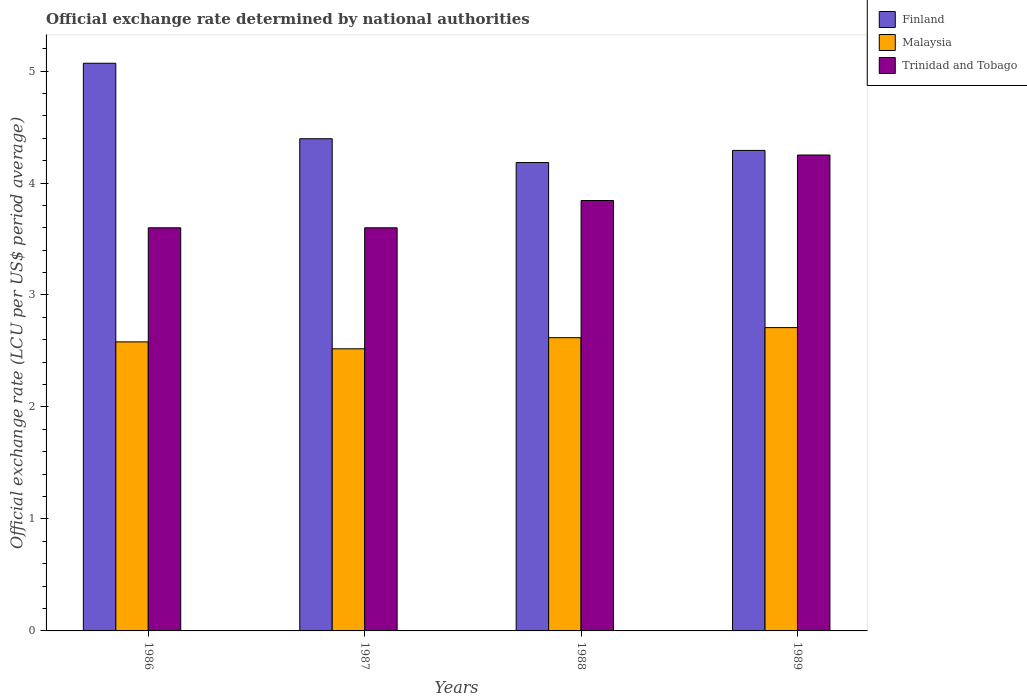Are the number of bars on each tick of the X-axis equal?
Your answer should be compact. Yes. How many bars are there on the 3rd tick from the left?
Offer a very short reply. 3. What is the official exchange rate in Finland in 1987?
Keep it short and to the point. 4.4. Across all years, what is the maximum official exchange rate in Finland?
Make the answer very short. 5.07. In which year was the official exchange rate in Finland minimum?
Ensure brevity in your answer.  1988. What is the total official exchange rate in Trinidad and Tobago in the graph?
Give a very brief answer. 15.29. What is the difference between the official exchange rate in Malaysia in 1988 and the official exchange rate in Trinidad and Tobago in 1989?
Offer a terse response. -1.63. What is the average official exchange rate in Trinidad and Tobago per year?
Ensure brevity in your answer.  3.82. In the year 1986, what is the difference between the official exchange rate in Trinidad and Tobago and official exchange rate in Finland?
Your response must be concise. -1.47. In how many years, is the official exchange rate in Trinidad and Tobago greater than 1.4 LCU?
Keep it short and to the point. 4. What is the ratio of the official exchange rate in Finland in 1987 to that in 1989?
Offer a terse response. 1.02. Is the official exchange rate in Trinidad and Tobago in 1986 less than that in 1989?
Ensure brevity in your answer.  Yes. Is the difference between the official exchange rate in Trinidad and Tobago in 1988 and 1989 greater than the difference between the official exchange rate in Finland in 1988 and 1989?
Keep it short and to the point. No. What is the difference between the highest and the second highest official exchange rate in Finland?
Ensure brevity in your answer.  0.67. What is the difference between the highest and the lowest official exchange rate in Finland?
Keep it short and to the point. 0.89. What does the 3rd bar from the left in 1986 represents?
Your answer should be very brief. Trinidad and Tobago. What does the 1st bar from the right in 1988 represents?
Ensure brevity in your answer.  Trinidad and Tobago. How many bars are there?
Ensure brevity in your answer.  12. How many years are there in the graph?
Offer a very short reply. 4. What is the difference between two consecutive major ticks on the Y-axis?
Provide a short and direct response. 1. Are the values on the major ticks of Y-axis written in scientific E-notation?
Provide a short and direct response. No. Does the graph contain any zero values?
Offer a very short reply. No. Where does the legend appear in the graph?
Provide a succinct answer. Top right. How many legend labels are there?
Give a very brief answer. 3. What is the title of the graph?
Ensure brevity in your answer.  Official exchange rate determined by national authorities. Does "Kosovo" appear as one of the legend labels in the graph?
Give a very brief answer. No. What is the label or title of the X-axis?
Your answer should be very brief. Years. What is the label or title of the Y-axis?
Provide a succinct answer. Official exchange rate (LCU per US$ period average). What is the Official exchange rate (LCU per US$ period average) in Finland in 1986?
Ensure brevity in your answer.  5.07. What is the Official exchange rate (LCU per US$ period average) in Malaysia in 1986?
Provide a succinct answer. 2.58. What is the Official exchange rate (LCU per US$ period average) of Finland in 1987?
Ensure brevity in your answer.  4.4. What is the Official exchange rate (LCU per US$ period average) in Malaysia in 1987?
Your answer should be very brief. 2.52. What is the Official exchange rate (LCU per US$ period average) in Trinidad and Tobago in 1987?
Your response must be concise. 3.6. What is the Official exchange rate (LCU per US$ period average) in Finland in 1988?
Provide a succinct answer. 4.18. What is the Official exchange rate (LCU per US$ period average) of Malaysia in 1988?
Offer a very short reply. 2.62. What is the Official exchange rate (LCU per US$ period average) of Trinidad and Tobago in 1988?
Give a very brief answer. 3.84. What is the Official exchange rate (LCU per US$ period average) of Finland in 1989?
Provide a short and direct response. 4.29. What is the Official exchange rate (LCU per US$ period average) of Malaysia in 1989?
Give a very brief answer. 2.71. What is the Official exchange rate (LCU per US$ period average) in Trinidad and Tobago in 1989?
Your response must be concise. 4.25. Across all years, what is the maximum Official exchange rate (LCU per US$ period average) in Finland?
Ensure brevity in your answer.  5.07. Across all years, what is the maximum Official exchange rate (LCU per US$ period average) in Malaysia?
Provide a succinct answer. 2.71. Across all years, what is the maximum Official exchange rate (LCU per US$ period average) of Trinidad and Tobago?
Provide a short and direct response. 4.25. Across all years, what is the minimum Official exchange rate (LCU per US$ period average) of Finland?
Give a very brief answer. 4.18. Across all years, what is the minimum Official exchange rate (LCU per US$ period average) in Malaysia?
Provide a short and direct response. 2.52. What is the total Official exchange rate (LCU per US$ period average) in Finland in the graph?
Ensure brevity in your answer.  17.94. What is the total Official exchange rate (LCU per US$ period average) in Malaysia in the graph?
Your response must be concise. 10.43. What is the total Official exchange rate (LCU per US$ period average) in Trinidad and Tobago in the graph?
Your answer should be compact. 15.29. What is the difference between the Official exchange rate (LCU per US$ period average) in Finland in 1986 and that in 1987?
Provide a short and direct response. 0.67. What is the difference between the Official exchange rate (LCU per US$ period average) in Malaysia in 1986 and that in 1987?
Your answer should be compact. 0.06. What is the difference between the Official exchange rate (LCU per US$ period average) of Trinidad and Tobago in 1986 and that in 1987?
Provide a short and direct response. 0. What is the difference between the Official exchange rate (LCU per US$ period average) of Finland in 1986 and that in 1988?
Your response must be concise. 0.89. What is the difference between the Official exchange rate (LCU per US$ period average) in Malaysia in 1986 and that in 1988?
Offer a terse response. -0.04. What is the difference between the Official exchange rate (LCU per US$ period average) of Trinidad and Tobago in 1986 and that in 1988?
Provide a short and direct response. -0.24. What is the difference between the Official exchange rate (LCU per US$ period average) of Finland in 1986 and that in 1989?
Your answer should be compact. 0.78. What is the difference between the Official exchange rate (LCU per US$ period average) in Malaysia in 1986 and that in 1989?
Give a very brief answer. -0.13. What is the difference between the Official exchange rate (LCU per US$ period average) of Trinidad and Tobago in 1986 and that in 1989?
Make the answer very short. -0.65. What is the difference between the Official exchange rate (LCU per US$ period average) of Finland in 1987 and that in 1988?
Offer a very short reply. 0.21. What is the difference between the Official exchange rate (LCU per US$ period average) in Malaysia in 1987 and that in 1988?
Your answer should be compact. -0.1. What is the difference between the Official exchange rate (LCU per US$ period average) in Trinidad and Tobago in 1987 and that in 1988?
Offer a very short reply. -0.24. What is the difference between the Official exchange rate (LCU per US$ period average) in Finland in 1987 and that in 1989?
Your response must be concise. 0.1. What is the difference between the Official exchange rate (LCU per US$ period average) of Malaysia in 1987 and that in 1989?
Keep it short and to the point. -0.19. What is the difference between the Official exchange rate (LCU per US$ period average) of Trinidad and Tobago in 1987 and that in 1989?
Offer a terse response. -0.65. What is the difference between the Official exchange rate (LCU per US$ period average) of Finland in 1988 and that in 1989?
Your answer should be very brief. -0.11. What is the difference between the Official exchange rate (LCU per US$ period average) of Malaysia in 1988 and that in 1989?
Ensure brevity in your answer.  -0.09. What is the difference between the Official exchange rate (LCU per US$ period average) of Trinidad and Tobago in 1988 and that in 1989?
Your answer should be very brief. -0.41. What is the difference between the Official exchange rate (LCU per US$ period average) of Finland in 1986 and the Official exchange rate (LCU per US$ period average) of Malaysia in 1987?
Offer a terse response. 2.55. What is the difference between the Official exchange rate (LCU per US$ period average) of Finland in 1986 and the Official exchange rate (LCU per US$ period average) of Trinidad and Tobago in 1987?
Give a very brief answer. 1.47. What is the difference between the Official exchange rate (LCU per US$ period average) in Malaysia in 1986 and the Official exchange rate (LCU per US$ period average) in Trinidad and Tobago in 1987?
Keep it short and to the point. -1.02. What is the difference between the Official exchange rate (LCU per US$ period average) in Finland in 1986 and the Official exchange rate (LCU per US$ period average) in Malaysia in 1988?
Offer a terse response. 2.45. What is the difference between the Official exchange rate (LCU per US$ period average) of Finland in 1986 and the Official exchange rate (LCU per US$ period average) of Trinidad and Tobago in 1988?
Ensure brevity in your answer.  1.23. What is the difference between the Official exchange rate (LCU per US$ period average) in Malaysia in 1986 and the Official exchange rate (LCU per US$ period average) in Trinidad and Tobago in 1988?
Offer a very short reply. -1.26. What is the difference between the Official exchange rate (LCU per US$ period average) in Finland in 1986 and the Official exchange rate (LCU per US$ period average) in Malaysia in 1989?
Offer a very short reply. 2.36. What is the difference between the Official exchange rate (LCU per US$ period average) of Finland in 1986 and the Official exchange rate (LCU per US$ period average) of Trinidad and Tobago in 1989?
Keep it short and to the point. 0.82. What is the difference between the Official exchange rate (LCU per US$ period average) of Malaysia in 1986 and the Official exchange rate (LCU per US$ period average) of Trinidad and Tobago in 1989?
Provide a succinct answer. -1.67. What is the difference between the Official exchange rate (LCU per US$ period average) in Finland in 1987 and the Official exchange rate (LCU per US$ period average) in Malaysia in 1988?
Keep it short and to the point. 1.78. What is the difference between the Official exchange rate (LCU per US$ period average) in Finland in 1987 and the Official exchange rate (LCU per US$ period average) in Trinidad and Tobago in 1988?
Your answer should be compact. 0.55. What is the difference between the Official exchange rate (LCU per US$ period average) of Malaysia in 1987 and the Official exchange rate (LCU per US$ period average) of Trinidad and Tobago in 1988?
Provide a short and direct response. -1.32. What is the difference between the Official exchange rate (LCU per US$ period average) of Finland in 1987 and the Official exchange rate (LCU per US$ period average) of Malaysia in 1989?
Offer a terse response. 1.69. What is the difference between the Official exchange rate (LCU per US$ period average) in Finland in 1987 and the Official exchange rate (LCU per US$ period average) in Trinidad and Tobago in 1989?
Provide a succinct answer. 0.15. What is the difference between the Official exchange rate (LCU per US$ period average) of Malaysia in 1987 and the Official exchange rate (LCU per US$ period average) of Trinidad and Tobago in 1989?
Ensure brevity in your answer.  -1.73. What is the difference between the Official exchange rate (LCU per US$ period average) in Finland in 1988 and the Official exchange rate (LCU per US$ period average) in Malaysia in 1989?
Give a very brief answer. 1.47. What is the difference between the Official exchange rate (LCU per US$ period average) of Finland in 1988 and the Official exchange rate (LCU per US$ period average) of Trinidad and Tobago in 1989?
Provide a succinct answer. -0.07. What is the difference between the Official exchange rate (LCU per US$ period average) in Malaysia in 1988 and the Official exchange rate (LCU per US$ period average) in Trinidad and Tobago in 1989?
Ensure brevity in your answer.  -1.63. What is the average Official exchange rate (LCU per US$ period average) in Finland per year?
Offer a very short reply. 4.48. What is the average Official exchange rate (LCU per US$ period average) of Malaysia per year?
Make the answer very short. 2.61. What is the average Official exchange rate (LCU per US$ period average) in Trinidad and Tobago per year?
Keep it short and to the point. 3.82. In the year 1986, what is the difference between the Official exchange rate (LCU per US$ period average) of Finland and Official exchange rate (LCU per US$ period average) of Malaysia?
Your answer should be compact. 2.49. In the year 1986, what is the difference between the Official exchange rate (LCU per US$ period average) of Finland and Official exchange rate (LCU per US$ period average) of Trinidad and Tobago?
Your answer should be compact. 1.47. In the year 1986, what is the difference between the Official exchange rate (LCU per US$ period average) of Malaysia and Official exchange rate (LCU per US$ period average) of Trinidad and Tobago?
Provide a succinct answer. -1.02. In the year 1987, what is the difference between the Official exchange rate (LCU per US$ period average) in Finland and Official exchange rate (LCU per US$ period average) in Malaysia?
Ensure brevity in your answer.  1.88. In the year 1987, what is the difference between the Official exchange rate (LCU per US$ period average) in Finland and Official exchange rate (LCU per US$ period average) in Trinidad and Tobago?
Your answer should be very brief. 0.8. In the year 1987, what is the difference between the Official exchange rate (LCU per US$ period average) of Malaysia and Official exchange rate (LCU per US$ period average) of Trinidad and Tobago?
Offer a very short reply. -1.08. In the year 1988, what is the difference between the Official exchange rate (LCU per US$ period average) in Finland and Official exchange rate (LCU per US$ period average) in Malaysia?
Keep it short and to the point. 1.56. In the year 1988, what is the difference between the Official exchange rate (LCU per US$ period average) of Finland and Official exchange rate (LCU per US$ period average) of Trinidad and Tobago?
Your response must be concise. 0.34. In the year 1988, what is the difference between the Official exchange rate (LCU per US$ period average) in Malaysia and Official exchange rate (LCU per US$ period average) in Trinidad and Tobago?
Your answer should be compact. -1.23. In the year 1989, what is the difference between the Official exchange rate (LCU per US$ period average) in Finland and Official exchange rate (LCU per US$ period average) in Malaysia?
Ensure brevity in your answer.  1.58. In the year 1989, what is the difference between the Official exchange rate (LCU per US$ period average) of Finland and Official exchange rate (LCU per US$ period average) of Trinidad and Tobago?
Your response must be concise. 0.04. In the year 1989, what is the difference between the Official exchange rate (LCU per US$ period average) of Malaysia and Official exchange rate (LCU per US$ period average) of Trinidad and Tobago?
Provide a short and direct response. -1.54. What is the ratio of the Official exchange rate (LCU per US$ period average) in Finland in 1986 to that in 1987?
Your answer should be compact. 1.15. What is the ratio of the Official exchange rate (LCU per US$ period average) in Malaysia in 1986 to that in 1987?
Offer a terse response. 1.02. What is the ratio of the Official exchange rate (LCU per US$ period average) in Finland in 1986 to that in 1988?
Your response must be concise. 1.21. What is the ratio of the Official exchange rate (LCU per US$ period average) of Malaysia in 1986 to that in 1988?
Your answer should be compact. 0.99. What is the ratio of the Official exchange rate (LCU per US$ period average) in Trinidad and Tobago in 1986 to that in 1988?
Your answer should be very brief. 0.94. What is the ratio of the Official exchange rate (LCU per US$ period average) of Finland in 1986 to that in 1989?
Keep it short and to the point. 1.18. What is the ratio of the Official exchange rate (LCU per US$ period average) in Malaysia in 1986 to that in 1989?
Provide a succinct answer. 0.95. What is the ratio of the Official exchange rate (LCU per US$ period average) in Trinidad and Tobago in 1986 to that in 1989?
Provide a short and direct response. 0.85. What is the ratio of the Official exchange rate (LCU per US$ period average) of Finland in 1987 to that in 1988?
Make the answer very short. 1.05. What is the ratio of the Official exchange rate (LCU per US$ period average) of Malaysia in 1987 to that in 1988?
Your answer should be very brief. 0.96. What is the ratio of the Official exchange rate (LCU per US$ period average) in Trinidad and Tobago in 1987 to that in 1988?
Offer a very short reply. 0.94. What is the ratio of the Official exchange rate (LCU per US$ period average) of Finland in 1987 to that in 1989?
Your answer should be compact. 1.02. What is the ratio of the Official exchange rate (LCU per US$ period average) of Malaysia in 1987 to that in 1989?
Make the answer very short. 0.93. What is the ratio of the Official exchange rate (LCU per US$ period average) of Trinidad and Tobago in 1987 to that in 1989?
Ensure brevity in your answer.  0.85. What is the ratio of the Official exchange rate (LCU per US$ period average) in Finland in 1988 to that in 1989?
Provide a short and direct response. 0.97. What is the ratio of the Official exchange rate (LCU per US$ period average) in Malaysia in 1988 to that in 1989?
Make the answer very short. 0.97. What is the ratio of the Official exchange rate (LCU per US$ period average) in Trinidad and Tobago in 1988 to that in 1989?
Keep it short and to the point. 0.9. What is the difference between the highest and the second highest Official exchange rate (LCU per US$ period average) in Finland?
Give a very brief answer. 0.67. What is the difference between the highest and the second highest Official exchange rate (LCU per US$ period average) of Malaysia?
Make the answer very short. 0.09. What is the difference between the highest and the second highest Official exchange rate (LCU per US$ period average) of Trinidad and Tobago?
Give a very brief answer. 0.41. What is the difference between the highest and the lowest Official exchange rate (LCU per US$ period average) in Finland?
Give a very brief answer. 0.89. What is the difference between the highest and the lowest Official exchange rate (LCU per US$ period average) in Malaysia?
Provide a short and direct response. 0.19. What is the difference between the highest and the lowest Official exchange rate (LCU per US$ period average) of Trinidad and Tobago?
Offer a terse response. 0.65. 